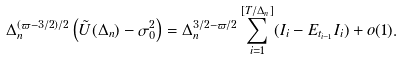Convert formula to latex. <formula><loc_0><loc_0><loc_500><loc_500>\Delta _ { n } ^ { ( { \varpi - 3 / 2 } ) / { 2 } } \left ( \tilde { U } ( \Delta _ { n } ) - \sigma _ { 0 } ^ { 2 } \right ) = \Delta _ { n } ^ { { 3 / 2 - \varpi } / { 2 } } \sum ^ { [ T / \Delta _ { n } ] } _ { i = 1 } ( I _ { i } - E _ { t _ { i - 1 } } I _ { i } ) + o ( 1 ) .</formula> 